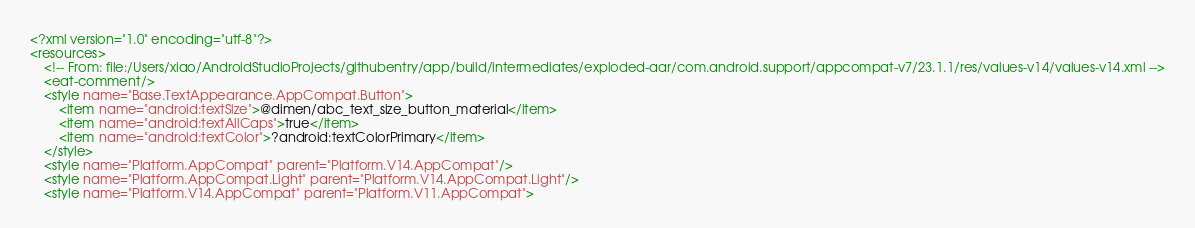<code> <loc_0><loc_0><loc_500><loc_500><_XML_><?xml version="1.0" encoding="utf-8"?>
<resources>
    <!-- From: file:/Users/xiao/AndroidStudioProjects/githubentry/app/build/intermediates/exploded-aar/com.android.support/appcompat-v7/23.1.1/res/values-v14/values-v14.xml -->
    <eat-comment/>
    <style name="Base.TextAppearance.AppCompat.Button">
        <item name="android:textSize">@dimen/abc_text_size_button_material</item>
        <item name="android:textAllCaps">true</item>
        <item name="android:textColor">?android:textColorPrimary</item>
    </style>
    <style name="Platform.AppCompat" parent="Platform.V14.AppCompat"/>
    <style name="Platform.AppCompat.Light" parent="Platform.V14.AppCompat.Light"/>
    <style name="Platform.V14.AppCompat" parent="Platform.V11.AppCompat"></code> 